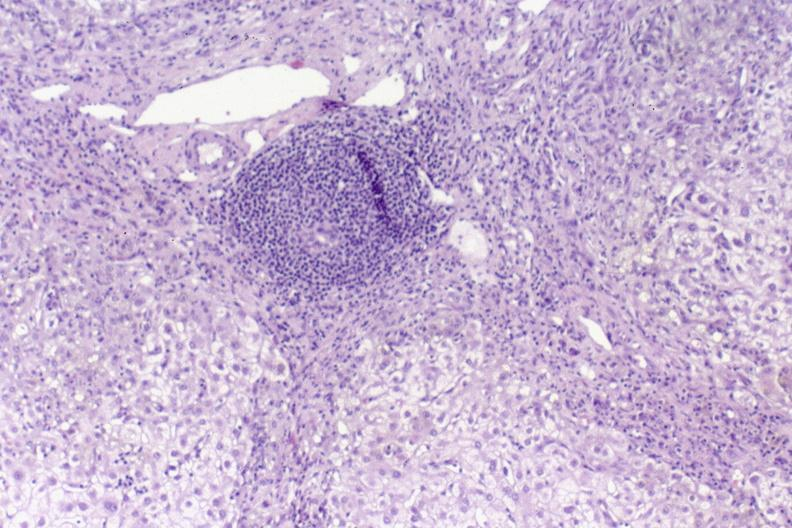s omphalocele present?
Answer the question using a single word or phrase. No 